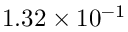<formula> <loc_0><loc_0><loc_500><loc_500>1 . 3 2 \times 1 0 ^ { - 1 }</formula> 